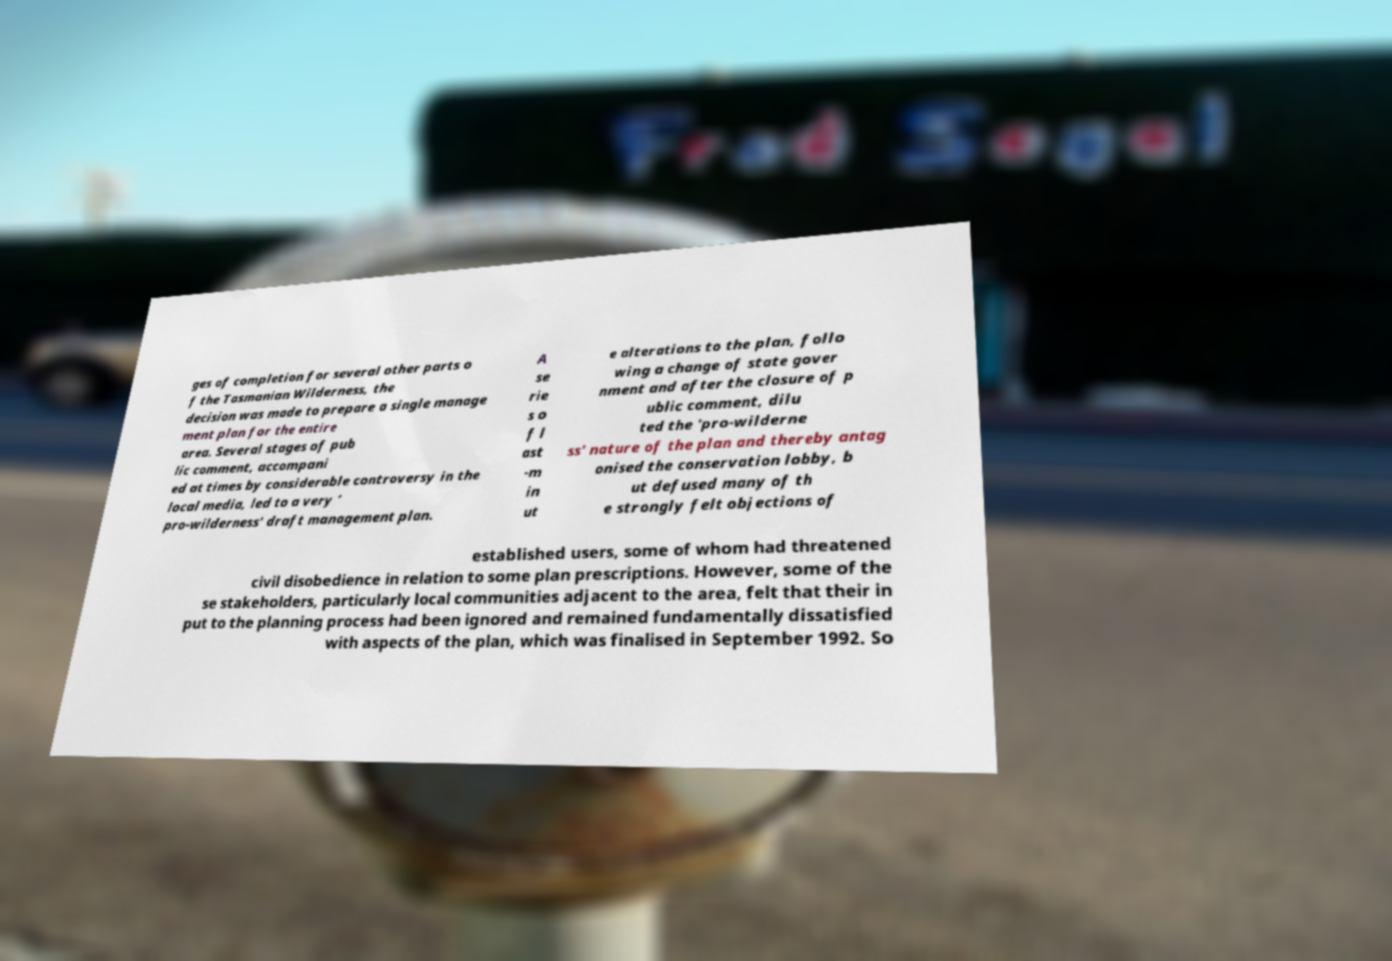Please read and relay the text visible in this image. What does it say? ges of completion for several other parts o f the Tasmanian Wilderness, the decision was made to prepare a single manage ment plan for the entire area. Several stages of pub lic comment, accompani ed at times by considerable controversy in the local media, led to a very ‘ pro-wilderness' draft management plan. A se rie s o f l ast -m in ut e alterations to the plan, follo wing a change of state gover nment and after the closure of p ublic comment, dilu ted the 'pro-wilderne ss' nature of the plan and thereby antag onised the conservation lobby, b ut defused many of th e strongly felt objections of established users, some of whom had threatened civil disobedience in relation to some plan prescriptions. However, some of the se stakeholders, particularly local communities adjacent to the area, felt that their in put to the planning process had been ignored and remained fundamentally dissatisfied with aspects of the plan, which was finalised in September 1992. So 